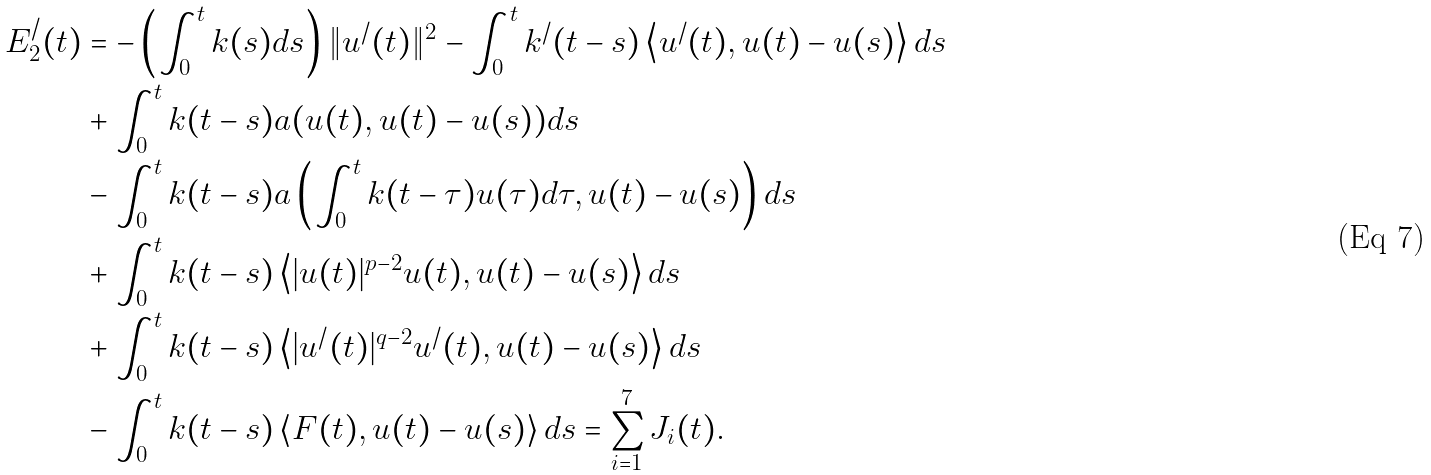Convert formula to latex. <formula><loc_0><loc_0><loc_500><loc_500>E _ { 2 } ^ { / } ( t ) & = - \left ( \int _ { 0 } ^ { t } k ( s ) d s \right ) \| u ^ { / } ( t ) \| ^ { 2 } - \int _ { 0 } ^ { t } k ^ { / } ( t - s ) \left < u ^ { / } ( t ) , u ( t ) - u ( s ) \right > d s \\ & + \int _ { 0 } ^ { t } k ( t - s ) a ( u ( t ) , u ( t ) - u ( s ) ) d s \\ & - \int _ { 0 } ^ { t } k ( t - s ) a \left ( \int _ { 0 } ^ { t } k ( t - \tau ) u ( \tau ) d \tau , u ( t ) - u ( s ) \right ) d s \\ & + \int _ { 0 } ^ { t } k ( t - s ) \left < | u ( t ) | ^ { p - 2 } u ( t ) , u ( t ) - u ( s ) \right > d s \\ & + \int _ { 0 } ^ { t } k ( t - s ) \left < | u ^ { / } ( t ) | ^ { q - 2 } u ^ { / } ( t ) , u ( t ) - u ( s ) \right > d s \\ & - \int _ { 0 } ^ { t } k ( t - s ) \left < F ( t ) , u ( t ) - u ( s ) \right > d s = \sum _ { i = 1 } ^ { 7 } J _ { i } ( t ) .</formula> 